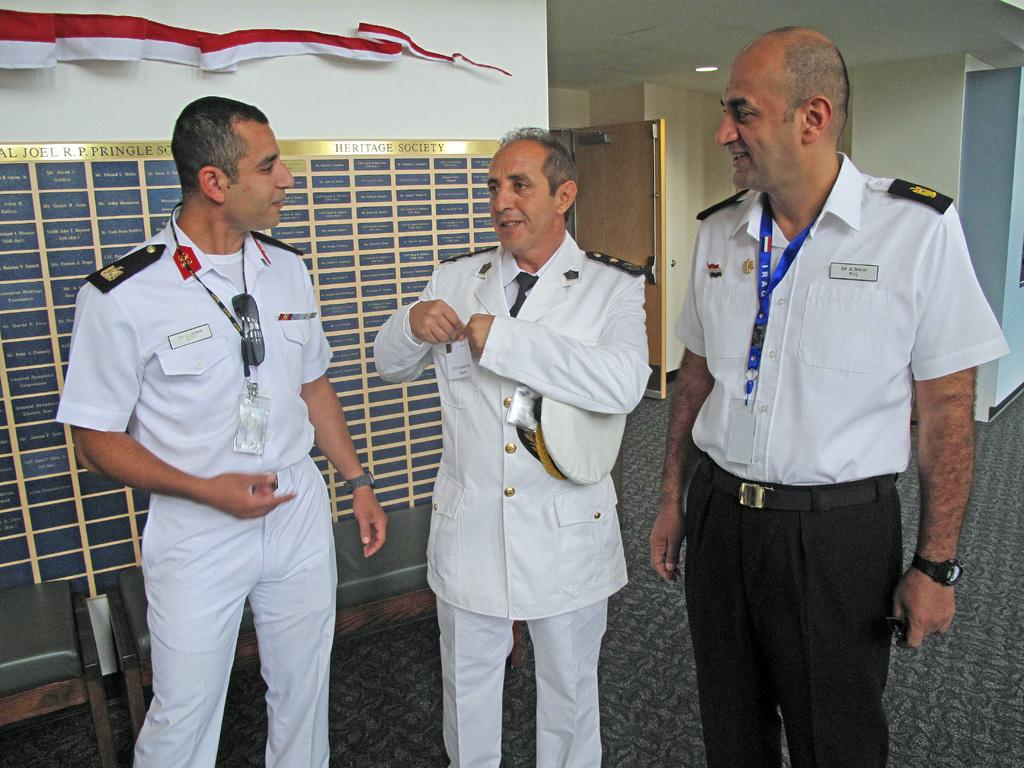How many people are standing in the image? There are three persons standing on the floor in the image. What can be seen in the image besides the people? There is a board, benches, cloth, a light, a door, and a wall visible in the image. What is the purpose of the board in the image? The purpose of the board in the image is not specified, but it could be used for displaying information or as a surface for writing or drawing. What type of lighting is present in the image? There is a light in the image, which provides illumination. What disease is being treated by the partner in the image? There is no partner or disease present in the image. 